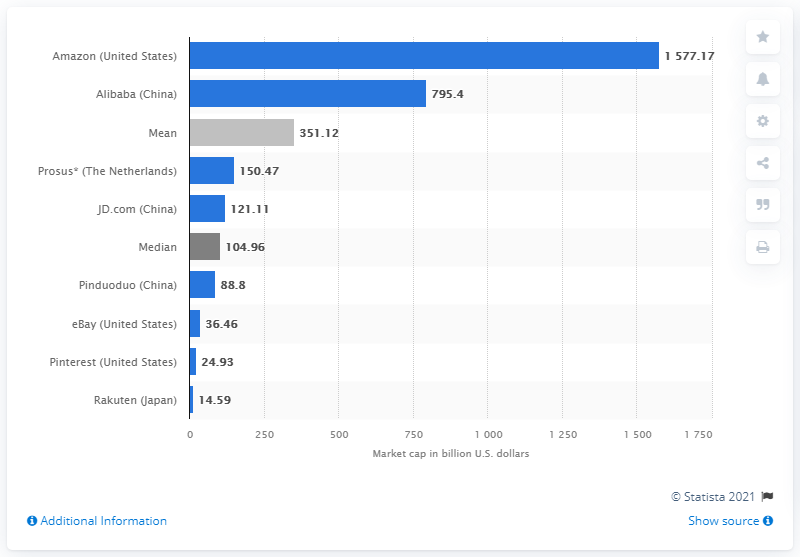Draw attention to some important aspects in this diagram. During the measured period, Alibaba's market capitalization was 795.4 billion dollars. 